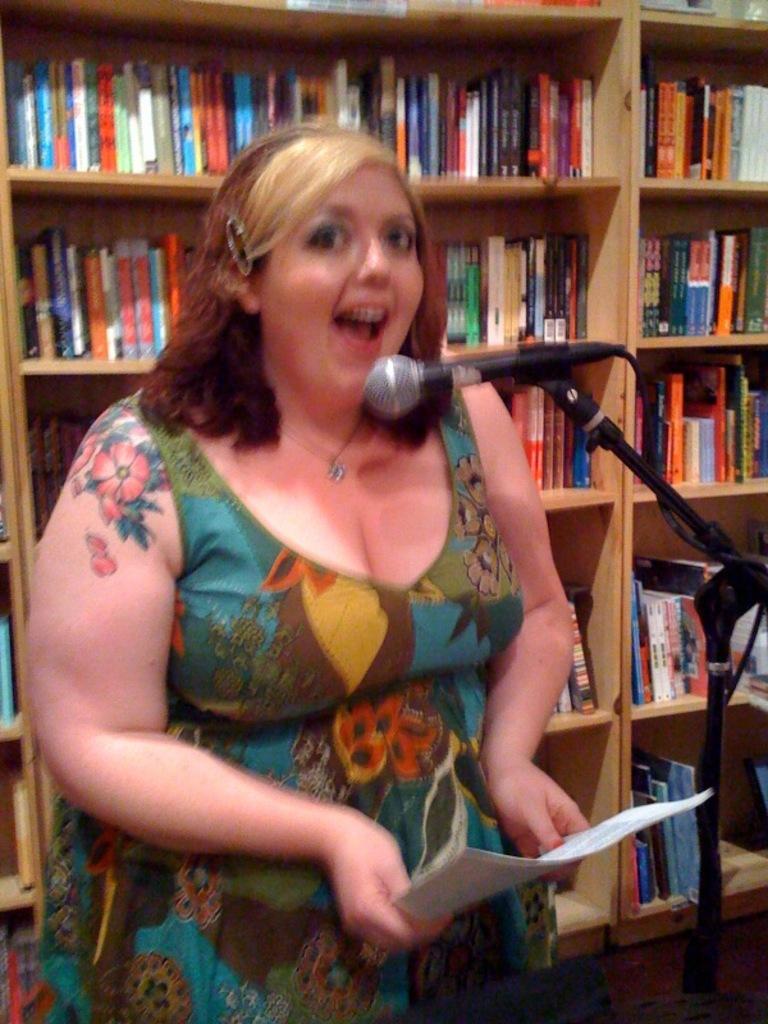Could you give a brief overview of what you see in this image? In the center of the image there is a woman standing at the mic with papers. In the background we can see many books arranged in shelves. 